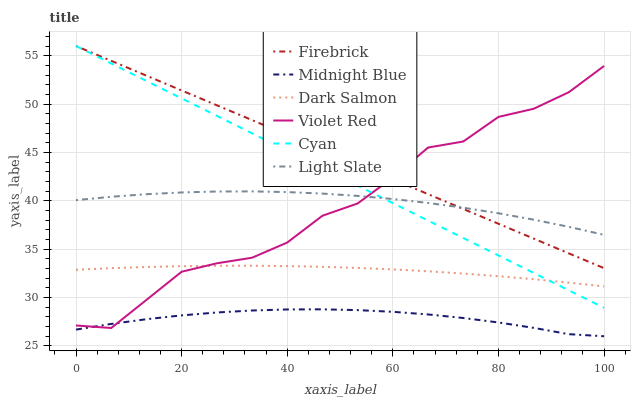Does Light Slate have the minimum area under the curve?
Answer yes or no. No. Does Light Slate have the maximum area under the curve?
Answer yes or no. No. Is Midnight Blue the smoothest?
Answer yes or no. No. Is Midnight Blue the roughest?
Answer yes or no. No. Does Light Slate have the lowest value?
Answer yes or no. No. Does Light Slate have the highest value?
Answer yes or no. No. Is Midnight Blue less than Light Slate?
Answer yes or no. Yes. Is Light Slate greater than Midnight Blue?
Answer yes or no. Yes. Does Midnight Blue intersect Light Slate?
Answer yes or no. No. 